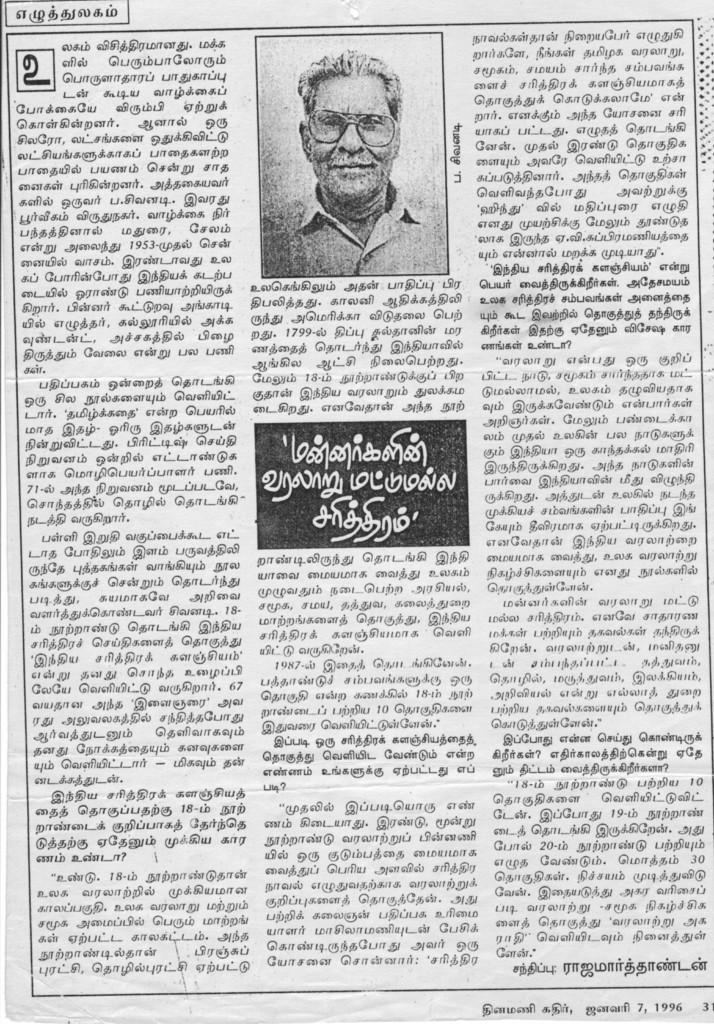What type of record can be seen in the image, and how does it relate to the humor and tax? There is no record present in the image, and therefore no such relationship can be observed. 